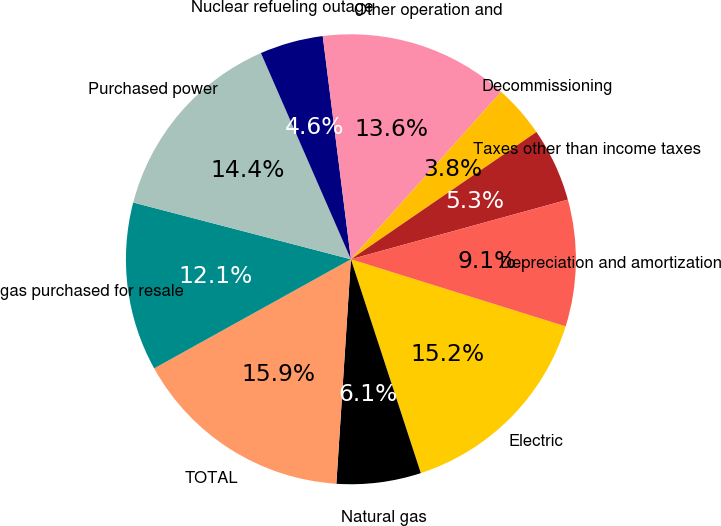Convert chart to OTSL. <chart><loc_0><loc_0><loc_500><loc_500><pie_chart><fcel>Electric<fcel>Natural gas<fcel>TOTAL<fcel>gas purchased for resale<fcel>Purchased power<fcel>Nuclear refueling outage<fcel>Other operation and<fcel>Decommissioning<fcel>Taxes other than income taxes<fcel>Depreciation and amortization<nl><fcel>15.15%<fcel>6.06%<fcel>15.91%<fcel>12.12%<fcel>14.39%<fcel>4.55%<fcel>13.64%<fcel>3.79%<fcel>5.3%<fcel>9.09%<nl></chart> 